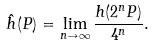Convert formula to latex. <formula><loc_0><loc_0><loc_500><loc_500>\hat { h } ( P ) = \lim _ { n \to \infty } \frac { h ( 2 ^ { n } P ) } { 4 ^ { n } } .</formula> 